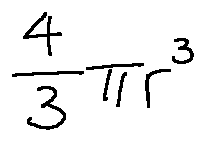<formula> <loc_0><loc_0><loc_500><loc_500>\frac { 4 } { 3 } \pi r ^ { 3 }</formula> 